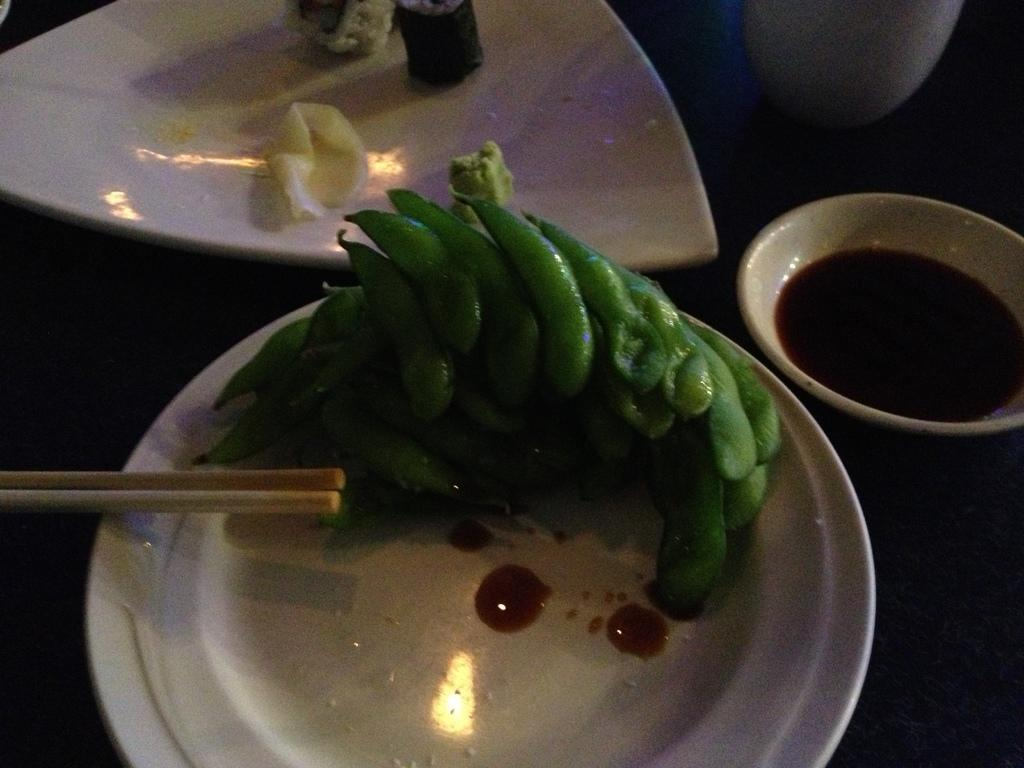What type of food can be seen in the image? The food in the image is in green color. What is the color of the plate that holds the food? The plate is in white color. How many sticks are visible in the image? There are two sticks in the image. What is the color of the bowl in the image? The bowl is in white color. What type of grass can be seen growing on the wall in the image? There is no grass or wall present in the image. 